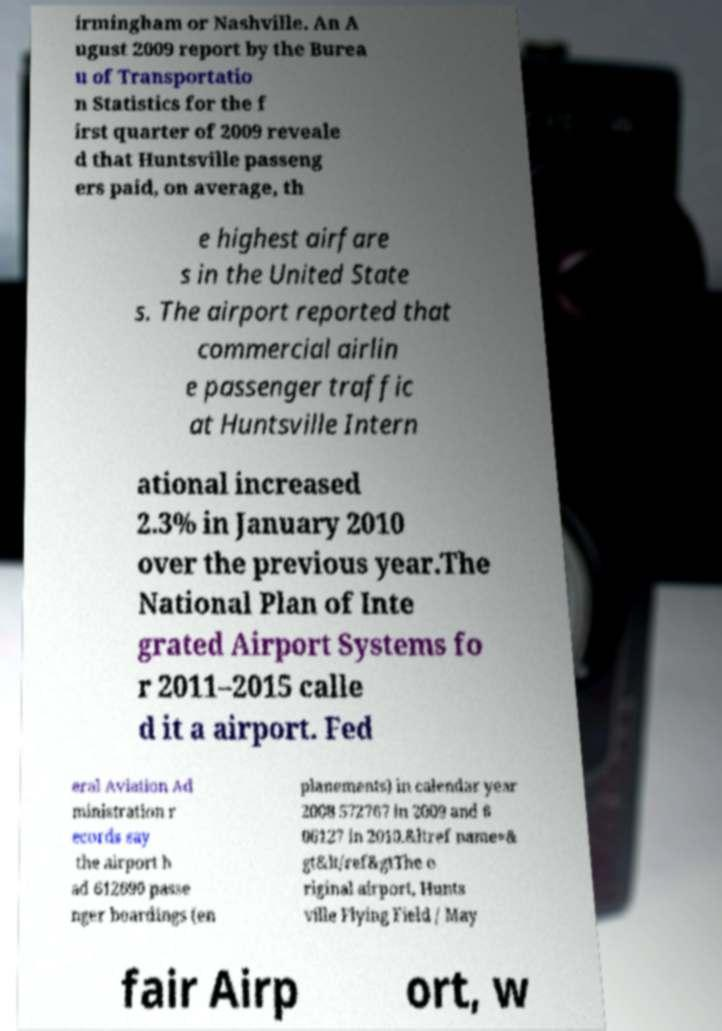Could you assist in decoding the text presented in this image and type it out clearly? irmingham or Nashville. An A ugust 2009 report by the Burea u of Transportatio n Statistics for the f irst quarter of 2009 reveale d that Huntsville passeng ers paid, on average, th e highest airfare s in the United State s. The airport reported that commercial airlin e passenger traffic at Huntsville Intern ational increased 2.3% in January 2010 over the previous year.The National Plan of Inte grated Airport Systems fo r 2011–2015 calle d it a airport. Fed eral Aviation Ad ministration r ecords say the airport h ad 612690 passe nger boardings (en planements) in calendar year 2008 572767 in 2009 and 6 06127 in 2010.&ltref name=& gt&lt/ref&gtThe o riginal airport, Hunts ville Flying Field / May fair Airp ort, w 